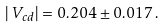<formula> <loc_0><loc_0><loc_500><loc_500>| \, V _ { c d } | = 0 . 2 0 4 \pm 0 . 0 1 7 \, .</formula> 